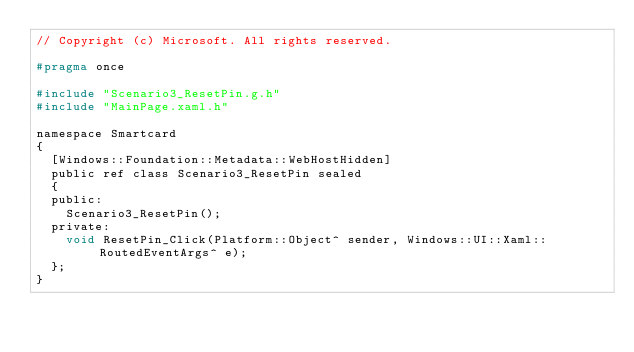Convert code to text. <code><loc_0><loc_0><loc_500><loc_500><_C_>// Copyright (c) Microsoft. All rights reserved.

#pragma once

#include "Scenario3_ResetPin.g.h"
#include "MainPage.xaml.h"

namespace Smartcard
{
	[Windows::Foundation::Metadata::WebHostHidden]
	public ref class Scenario3_ResetPin sealed
	{
	public:
		Scenario3_ResetPin();
	private:
		void ResetPin_Click(Platform::Object^ sender, Windows::UI::Xaml::RoutedEventArgs^ e);
	};
}</code> 